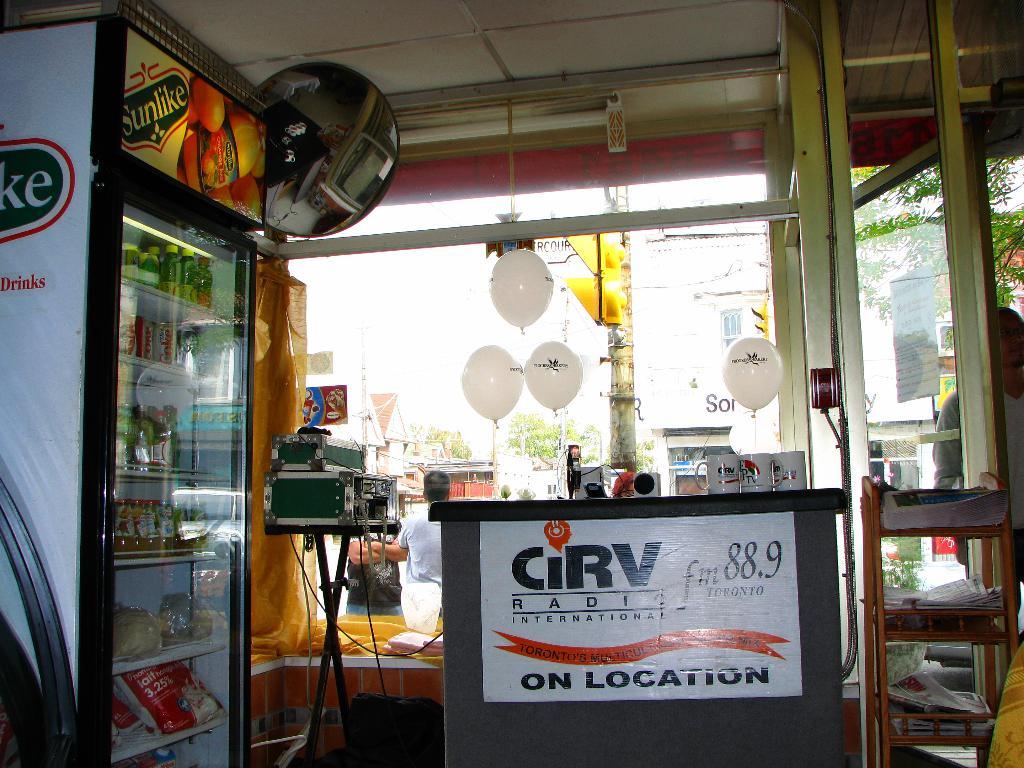What radio station is mentioned on the white sign?
Provide a succinct answer. 88.9. What is the name of this radio station being advertised?
Your response must be concise. Cirv. 